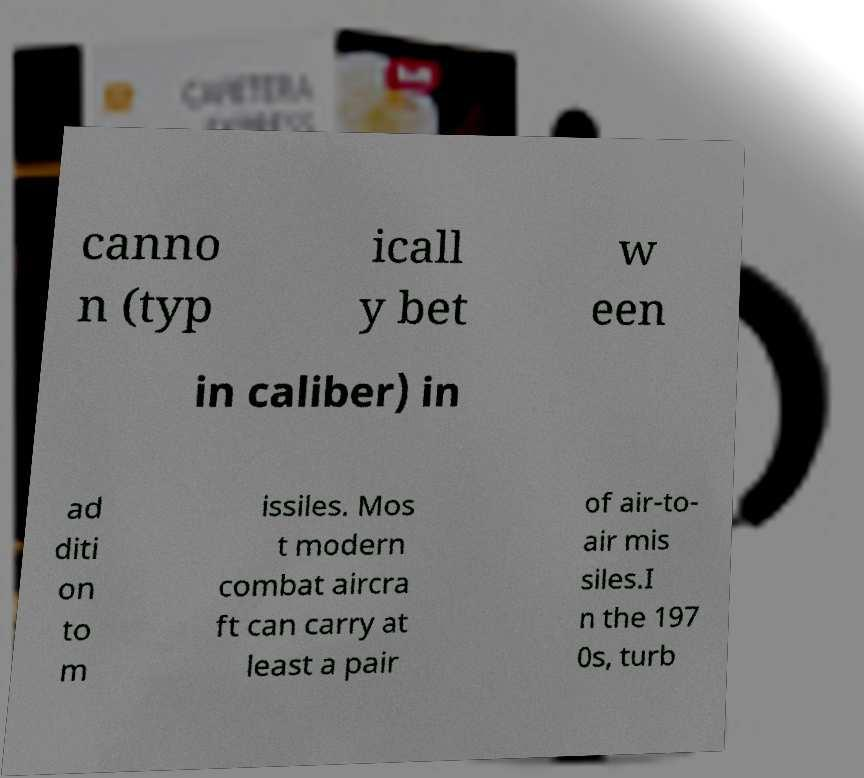I need the written content from this picture converted into text. Can you do that? canno n (typ icall y bet w een in caliber) in ad diti on to m issiles. Mos t modern combat aircra ft can carry at least a pair of air-to- air mis siles.I n the 197 0s, turb 